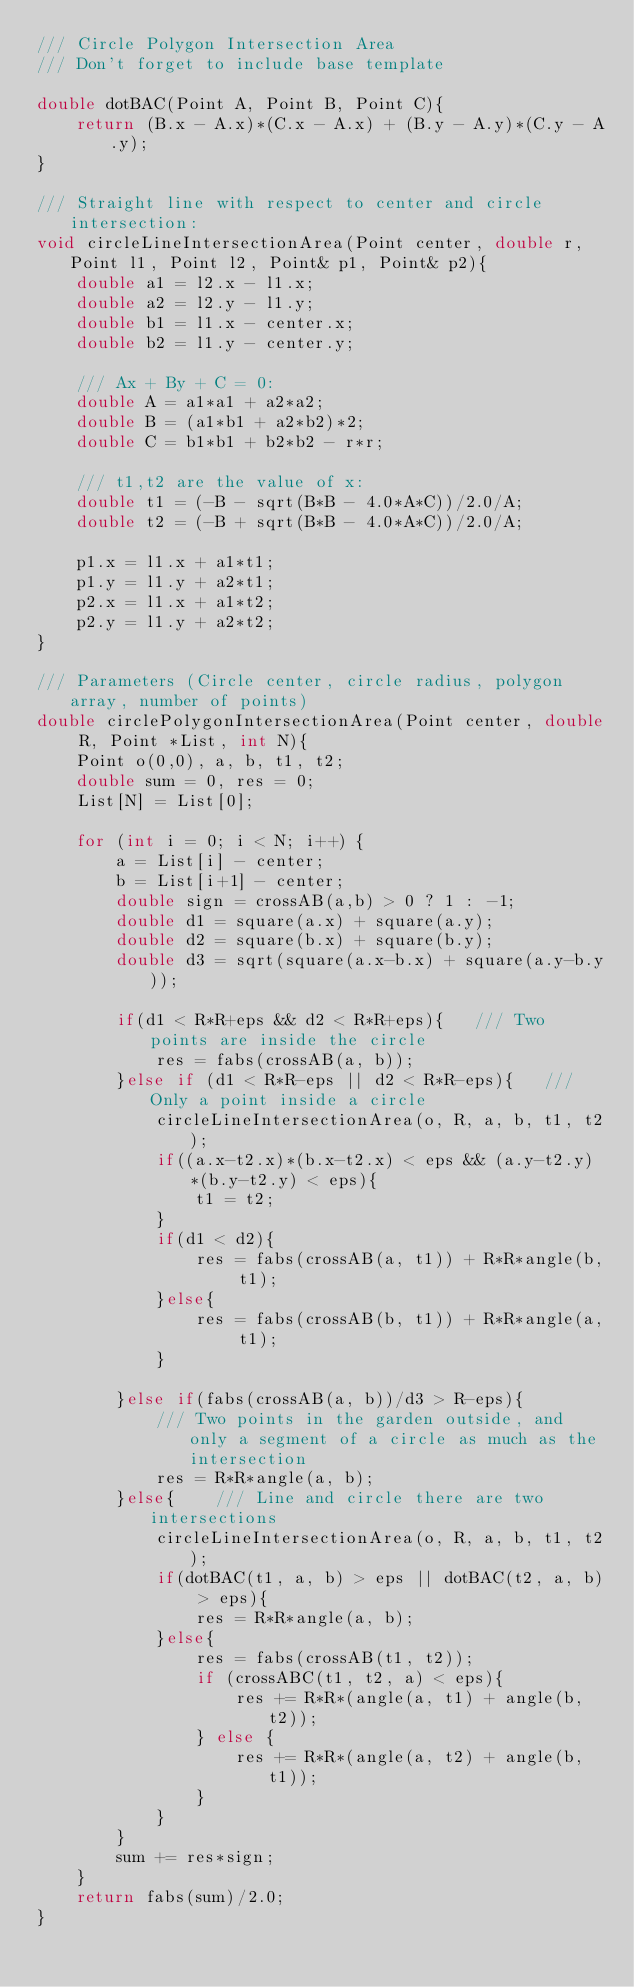Convert code to text. <code><loc_0><loc_0><loc_500><loc_500><_C++_>/// Circle Polygon Intersection Area
/// Don't forget to include base template

double dotBAC(Point A, Point B, Point C){
    return (B.x - A.x)*(C.x - A.x) + (B.y - A.y)*(C.y - A.y);
}

/// Straight line with respect to center and circle intersection:
void circleLineIntersectionArea(Point center, double r, Point l1, Point l2, Point& p1, Point& p2){
    double a1 = l2.x - l1.x;
    double a2 = l2.y - l1.y;
    double b1 = l1.x - center.x;
    double b2 = l1.y - center.y;

    /// Ax + By + C = 0:
    double A = a1*a1 + a2*a2;
    double B = (a1*b1 + a2*b2)*2;
    double C = b1*b1 + b2*b2 - r*r;

    /// t1,t2 are the value of x:
    double t1 = (-B - sqrt(B*B - 4.0*A*C))/2.0/A;
    double t2 = (-B + sqrt(B*B - 4.0*A*C))/2.0/A;

    p1.x = l1.x + a1*t1;
    p1.y = l1.y + a2*t1;
    p2.x = l1.x + a1*t2;
    p2.y = l1.y + a2*t2;
}

/// Parameters (Circle center, circle radius, polygon array, number of points)
double circlePolygonIntersectionArea(Point center, double R, Point *List, int N){
    Point o(0,0), a, b, t1, t2;
    double sum = 0, res = 0;
    List[N] = List[0];

    for (int i = 0; i < N; i++) {
        a = List[i] - center;
        b = List[i+1] - center;
        double sign = crossAB(a,b) > 0 ? 1 : -1;
        double d1 = square(a.x) + square(a.y);
        double d2 = square(b.x) + square(b.y);
        double d3 = sqrt(square(a.x-b.x) + square(a.y-b.y));

        if(d1 < R*R+eps && d2 < R*R+eps){   /// Two points are inside the circle
            res = fabs(crossAB(a, b));
        }else if (d1 < R*R-eps || d2 < R*R-eps){   /// Only a point inside a circle
            circleLineIntersectionArea(o, R, a, b, t1, t2);
            if((a.x-t2.x)*(b.x-t2.x) < eps && (a.y-t2.y)*(b.y-t2.y) < eps){
                t1 = t2;
            }
            if(d1 < d2){
                res = fabs(crossAB(a, t1)) + R*R*angle(b, t1);
            }else{
                res = fabs(crossAB(b, t1)) + R*R*angle(a, t1);
            }

        }else if(fabs(crossAB(a, b))/d3 > R-eps){
            /// Two points in the garden outside, and only a segment of a circle as much as the intersection
            res = R*R*angle(a, b);
        }else{    /// Line and circle there are two intersections
            circleLineIntersectionArea(o, R, a, b, t1, t2);
            if(dotBAC(t1, a, b) > eps || dotBAC(t2, a, b) > eps){
                res = R*R*angle(a, b);
            }else{
                res = fabs(crossAB(t1, t2));
                if (crossABC(t1, t2, a) < eps){
                    res += R*R*(angle(a, t1) + angle(b, t2));
                } else {
                    res += R*R*(angle(a, t2) + angle(b, t1));
                }
            }
        }
        sum += res*sign;
    }
    return fabs(sum)/2.0;
}
</code> 